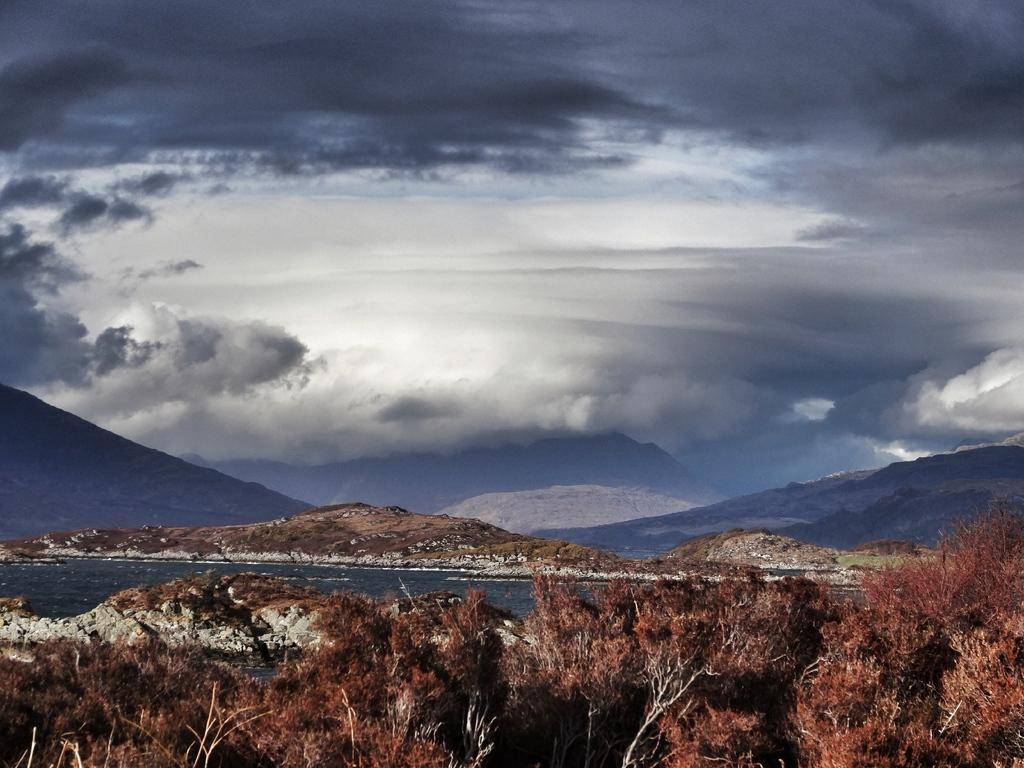What type of natural landform can be seen in the image? There are mountains in the image. What other natural elements are present in the image? There are trees and water visible in the image. What is visible at the top of the image? The sky is visible at the top of the image. What can be seen in the sky? There are clouds in the sky. Can you tell me how many animals are copying each other in the image? There are no animals present in the image, and therefore no such activity can be observed. 